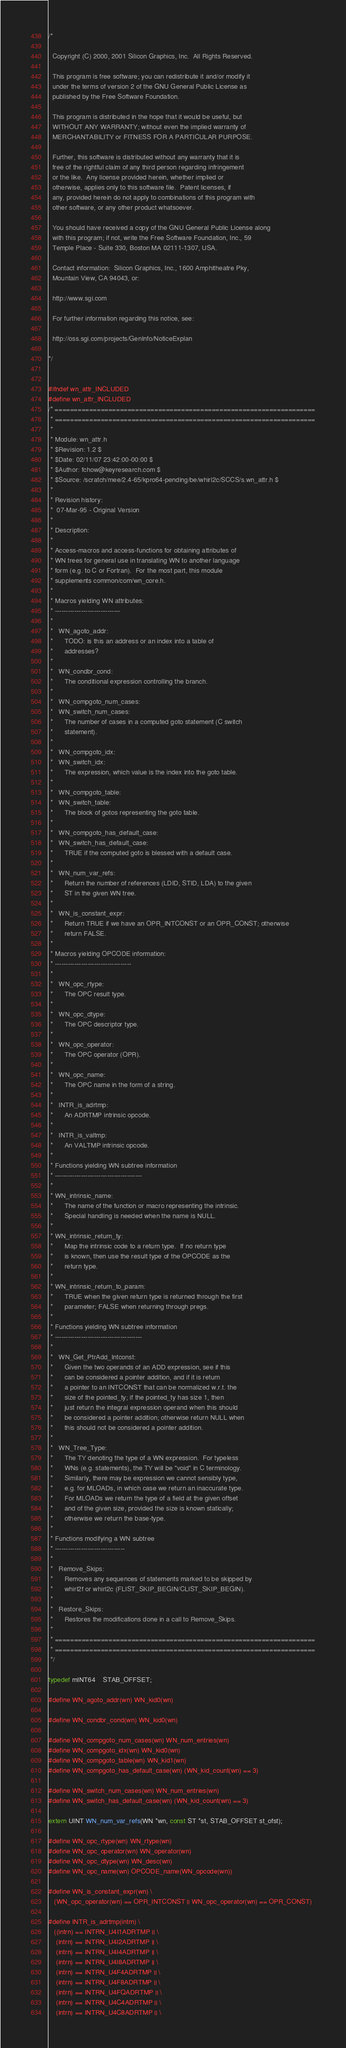Convert code to text. <code><loc_0><loc_0><loc_500><loc_500><_C_>/*

  Copyright (C) 2000, 2001 Silicon Graphics, Inc.  All Rights Reserved.

  This program is free software; you can redistribute it and/or modify it
  under the terms of version 2 of the GNU General Public License as
  published by the Free Software Foundation.

  This program is distributed in the hope that it would be useful, but
  WITHOUT ANY WARRANTY; without even the implied warranty of
  MERCHANTABILITY or FITNESS FOR A PARTICULAR PURPOSE.  

  Further, this software is distributed without any warranty that it is
  free of the rightful claim of any third person regarding infringement 
  or the like.  Any license provided herein, whether implied or 
  otherwise, applies only to this software file.  Patent licenses, if 
  any, provided herein do not apply to combinations of this program with 
  other software, or any other product whatsoever.  

  You should have received a copy of the GNU General Public License along
  with this program; if not, write the Free Software Foundation, Inc., 59
  Temple Place - Suite 330, Boston MA 02111-1307, USA.

  Contact information:  Silicon Graphics, Inc., 1600 Amphitheatre Pky,
  Mountain View, CA 94043, or:

  http://www.sgi.com

  For further information regarding this notice, see:

  http://oss.sgi.com/projects/GenInfo/NoticeExplan

*/


#ifndef wn_attr_INCLUDED
#define wn_attr_INCLUDED
/* ====================================================================
 * ====================================================================
 *
 * Module: wn_attr.h
 * $Revision: 1.2 $
 * $Date: 02/11/07 23:42:00-00:00 $
 * $Author: fchow@keyresearch.com $
 * $Source: /scratch/mee/2.4-65/kpro64-pending/be/whirl2c/SCCS/s.wn_attr.h $
 *
 * Revision history:
 *  07-Mar-95 - Original Version
 *
 * Description:
 *
 * Access-macros and access-functions for obtaining attributes of 
 * WN trees for general use in translating WN to another language
 * form (e.g. to C or Fortran).  For the most part, this module
 * supplements common/com/wn_core.h.
 *
 * Macros yielding WN attributes:
 * ------------------------------
 *
 *   WN_agoto_addr:
 *      TODO: is this an address or an index into a table of 
 *      addresses?
 *
 *   WN_condbr_cond:
 *      The conditional expression controlling the branch.
 *
 *   WN_compgoto_num_cases:
 *   WN_switch_num_cases:
 *      The number of cases in a computed goto statement (C switch
 *      statement).
 *
 *   WN_compgoto_idx:
 *   WN_switch_idx:
 *      The expression, which value is the index into the goto table.
 *
 *   WN_compgoto_table:
 *   WN_switch_table:
 *      The block of gotos representing the goto table.
 *
 *   WN_compgoto_has_default_case:
 *   WN_switch_has_default_case:
 *      TRUE if the computed goto is blessed with a default case.
 *
 *   WN_num_var_refs:
 *      Return the number of references (LDID, STID, LDA) to the given
 *      ST in the given WN tree.
 *
 *   WN_is_constant_expr:
 *      Return TRUE if we have an OPR_INTCONST or an OPR_CONST; otherwise
 *      return FALSE.
 *
 * Macros yielding OPCODE information:
 * -----------------------------------
 *
 *   WN_opc_rtype:
 *      The OPC result type.
 *
 *   WN_opc_dtype:
 *      The OPC descriptor type.
 *
 *   WN_opc_operator:
 *      The OPC operator (OPR).
 *
 *   WN_opc_name:
 *      The OPC name in the form of a string.
 *
 *   INTR_is_adrtmp:
 *      An ADRTMP intrinsic opcode.
 *
 *   INTR_is_valtmp:
 *      An VALTMP intrinsic opcode.
 *
 * Functions yielding WN subtree information
 * ----------------------------------------
 *
 * WN_intrinsic_name:
 *      The name of the function or macro representing the intrinsic.
 *      Special handling is needed when the name is NULL.
 *
 * WN_intrinsic_return_ty:
 *      Map the intrinsic code to a return type.  If no return type
 *      is known, then use the result type of the OPCODE as the
 *      return type.
 *
 * WN_intrinsic_return_to_param:
 *      TRUE when the given return type is returned through the first
 *      parameter; FALSE when returning through pregs.
 *
 * Functions yielding WN subtree information
 * ----------------------------------------
 *
 *   WN_Get_PtrAdd_Intconst:
 *      Given the two operands of an ADD expression, see if this
 *      can be considered a pointer addition, and if it is return
 *      a pointer to an INTCONST that can be normalized w.r.t. the
 *      size of the pointed_ty; if the pointed_ty has size 1, then
 *      just return the integral expression operand when this should
 *      be considered a pointer addition; otherwise return NULL when
 *      this should not be considered a pointer addition.
 *
 *   WN_Tree_Type:
 *      The TY denoting the type of a WN expression.  For typeless
 *      WNs (e.g. statements), the TY will be "void" in C terminology.
 *      Similarly, there may be expression we cannot sensibly type,
 *      e.g. for MLOADs, in which case we return an inaccurate type.
 *      For MLOADs we return the type of a field at the given offset
 *      and of the given size, provided the size is known statically;
 *      otherwise we return the base-type.
 *
 * Functions modifying a WN subtree
 * --------------------------------
 *
 *   Remove_Skips:
 *      Removes any sequences of statements marked to be skipped by
 *      whirl2f or whirl2c (FLIST_SKIP_BEGIN/CLIST_SKIP_BEGIN).
 *
 *   Restore_Skips:
 *      Restores the modifications done in a call to Remove_Skips.
 *
 * ====================================================================
 * ====================================================================
 */

typedef mINT64    STAB_OFFSET;

#define WN_agoto_addr(wn) WN_kid0(wn)

#define WN_condbr_cond(wn) WN_kid0(wn)

#define WN_compgoto_num_cases(wn) WN_num_entries(wn)
#define WN_compgoto_idx(wn) WN_kid0(wn)
#define WN_compgoto_table(wn) WN_kid1(wn)
#define WN_compgoto_has_default_case(wn) (WN_kid_count(wn) == 3)

#define WN_switch_num_cases(wn) WN_num_entries(wn)
#define WN_switch_has_default_case(wn) (WN_kid_count(wn) == 3)

extern UINT WN_num_var_refs(WN *wn, const ST *st, STAB_OFFSET st_ofst);

#define WN_opc_rtype(wn) WN_rtype(wn)
#define WN_opc_operator(wn) WN_operator(wn)
#define WN_opc_dtype(wn) WN_desc(wn)
#define WN_opc_name(wn) OPCODE_name(WN_opcode(wn))

#define WN_is_constant_expr(wn) \
   (WN_opc_operator(wn) == OPR_INTCONST || WN_opc_operator(wn) == OPR_CONST)

#define INTR_is_adrtmp(intrn) \
   ((intrn) == INTRN_U4I1ADRTMP || \
    (intrn) == INTRN_U4I2ADRTMP || \
    (intrn) == INTRN_U4I4ADRTMP || \
    (intrn) == INTRN_U4I8ADRTMP || \
    (intrn) == INTRN_U4F4ADRTMP || \
    (intrn) == INTRN_U4F8ADRTMP || \
    (intrn) == INTRN_U4FQADRTMP || \
    (intrn) == INTRN_U4C4ADRTMP || \
    (intrn) == INTRN_U4C8ADRTMP || \</code> 